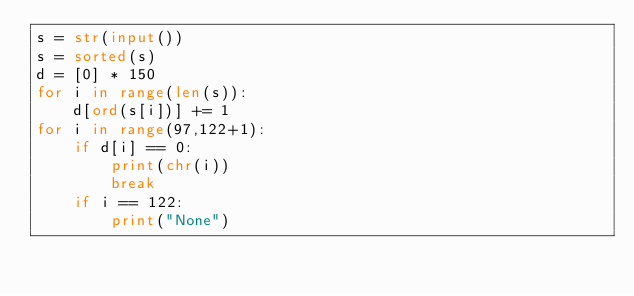Convert code to text. <code><loc_0><loc_0><loc_500><loc_500><_Python_>s = str(input())
s = sorted(s)
d = [0] * 150
for i in range(len(s)):
    d[ord(s[i])] += 1
for i in range(97,122+1):
    if d[i] == 0:
        print(chr(i))
        break
    if i == 122:
        print("None")</code> 